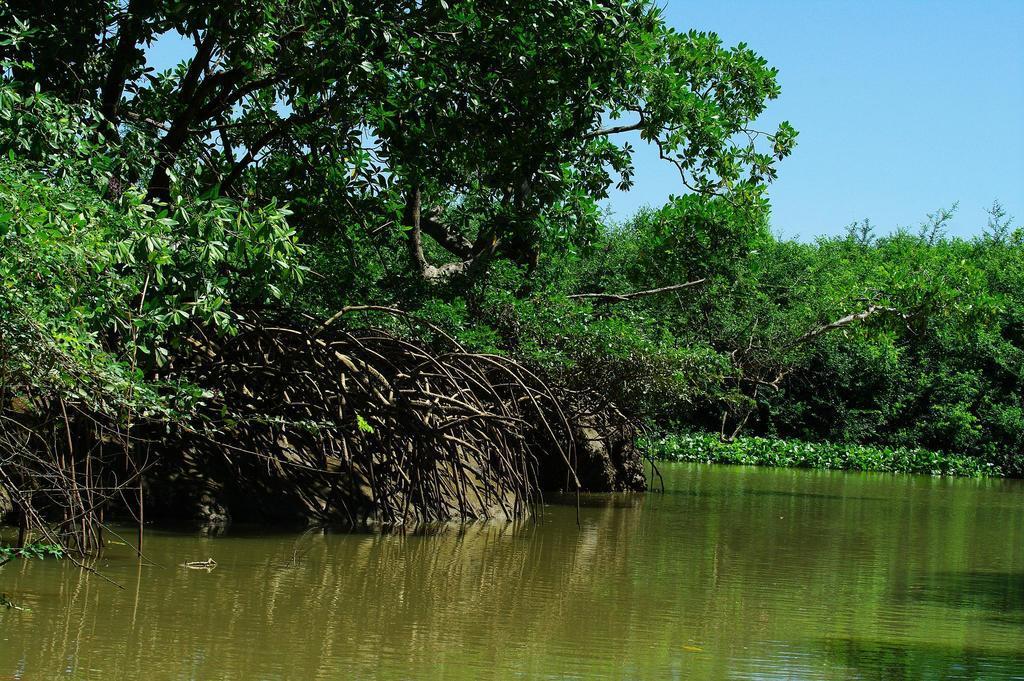Could you give a brief overview of what you see in this image? In this picture I can see water, trees and plants. In the background I can see the sky. 